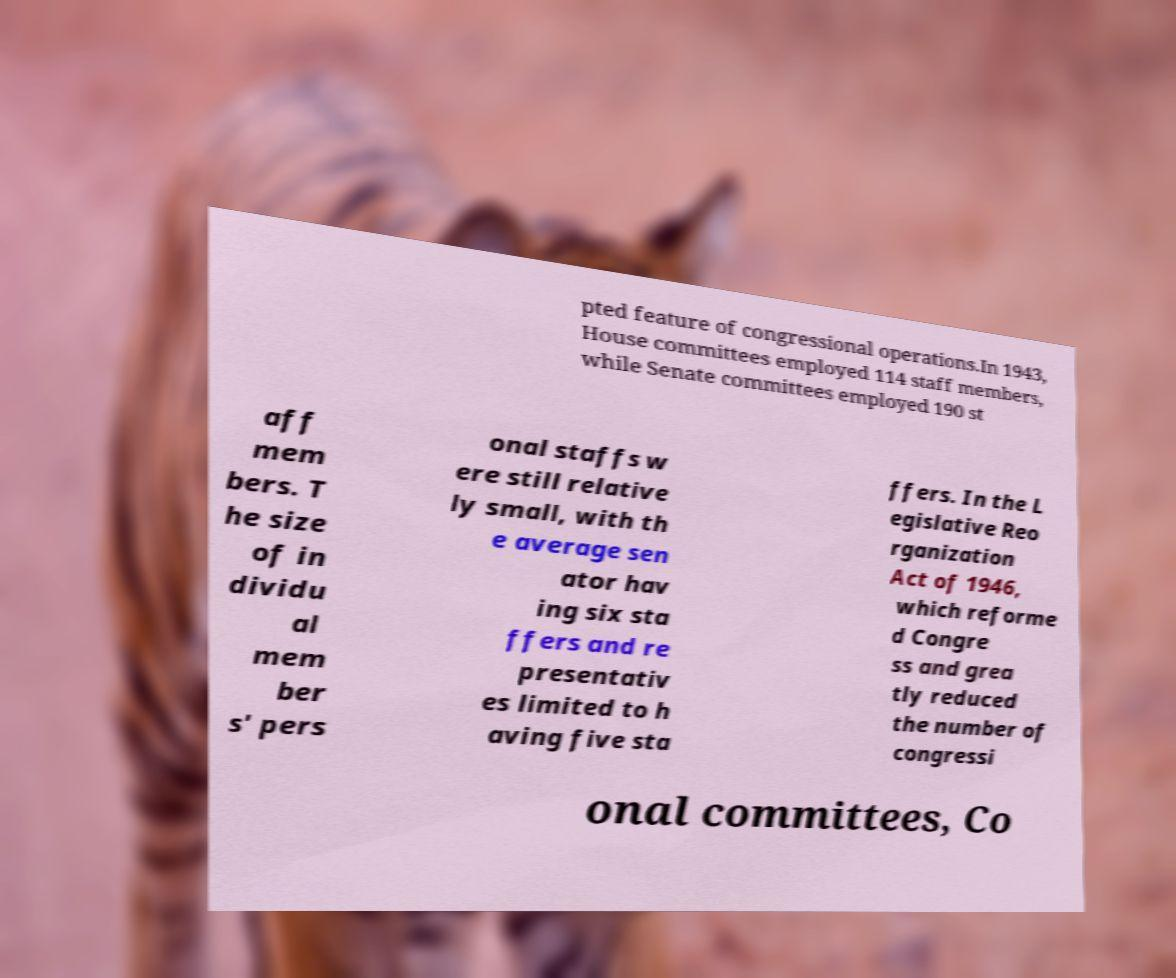What messages or text are displayed in this image? I need them in a readable, typed format. pted feature of congressional operations.In 1943, House committees employed 114 staff members, while Senate committees employed 190 st aff mem bers. T he size of in dividu al mem ber s' pers onal staffs w ere still relative ly small, with th e average sen ator hav ing six sta ffers and re presentativ es limited to h aving five sta ffers. In the L egislative Reo rganization Act of 1946, which reforme d Congre ss and grea tly reduced the number of congressi onal committees, Co 